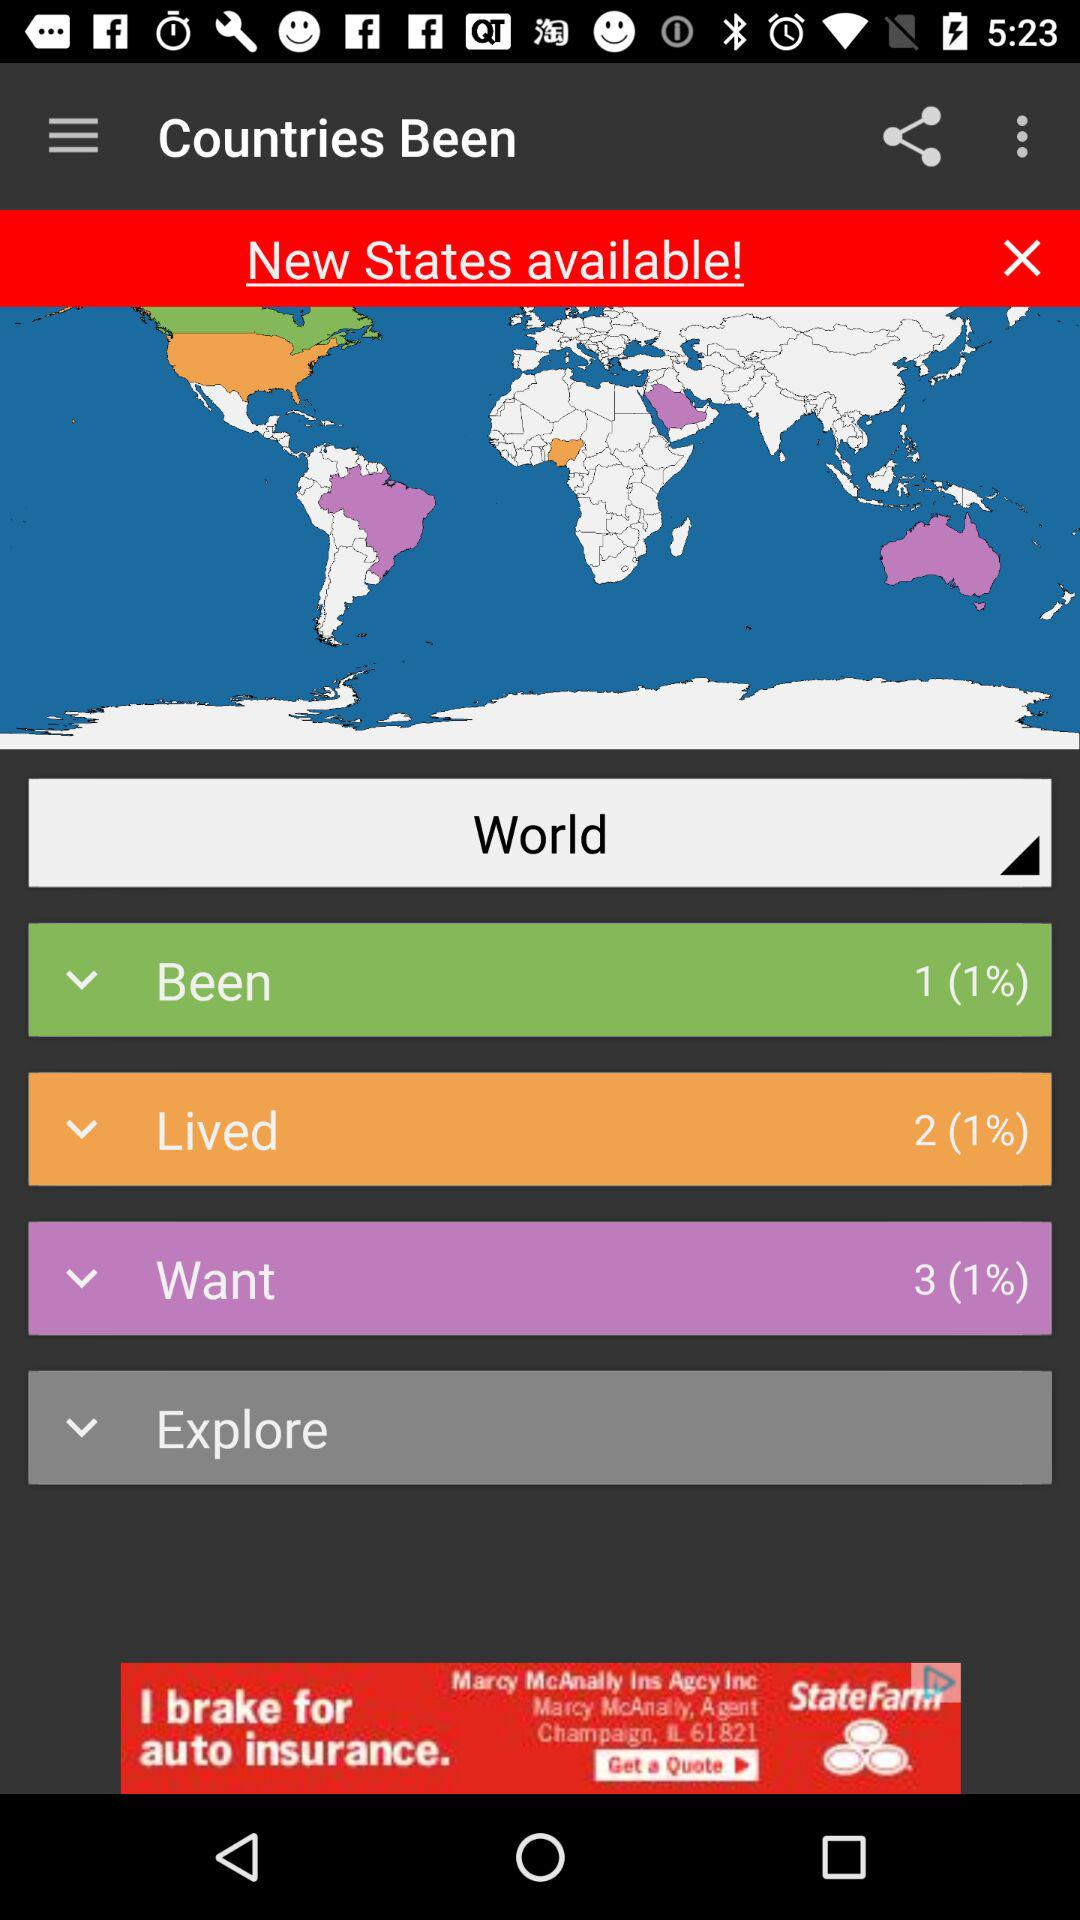How many countries have been visited? The number of countries that have been visited is 1. 